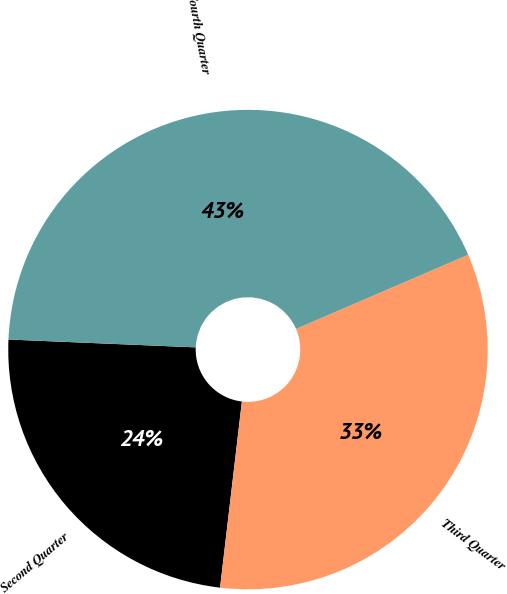Convert chart. <chart><loc_0><loc_0><loc_500><loc_500><pie_chart><fcel>Second Quarter<fcel>Third Quarter<fcel>Fourth Quarter<nl><fcel>23.81%<fcel>33.33%<fcel>42.86%<nl></chart> 